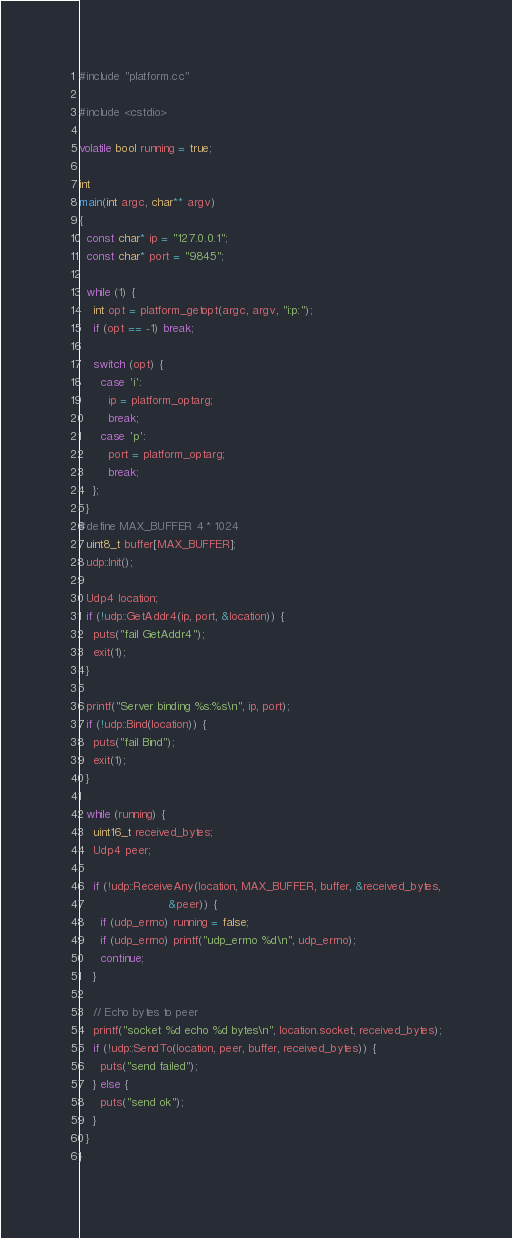<code> <loc_0><loc_0><loc_500><loc_500><_C++_>#include "platform.cc"

#include <cstdio>

volatile bool running = true;

int
main(int argc, char** argv)
{
  const char* ip = "127.0.0.1";
  const char* port = "9845";

  while (1) {
    int opt = platform_getopt(argc, argv, "i:p:");
    if (opt == -1) break;

    switch (opt) {
      case 'i':
        ip = platform_optarg;
        break;
      case 'p':
        port = platform_optarg;
        break;
    };
  }
#define MAX_BUFFER 4 * 1024
  uint8_t buffer[MAX_BUFFER];
  udp::Init();

  Udp4 location;
  if (!udp::GetAddr4(ip, port, &location)) {
    puts("fail GetAddr4");
    exit(1);
  }

  printf("Server binding %s:%s\n", ip, port);
  if (!udp::Bind(location)) {
    puts("fail Bind");
    exit(1);
  }

  while (running) {
    uint16_t received_bytes;
    Udp4 peer;

    if (!udp::ReceiveAny(location, MAX_BUFFER, buffer, &received_bytes,
                         &peer)) {
      if (udp_errno) running = false;
      if (udp_errno) printf("udp_errno %d\n", udp_errno);
      continue;
    }

    // Echo bytes to peer
    printf("socket %d echo %d bytes\n", location.socket, received_bytes);
    if (!udp::SendTo(location, peer, buffer, received_bytes)) {
      puts("send failed");
    } else {
      puts("send ok");
    }
  }
}
</code> 